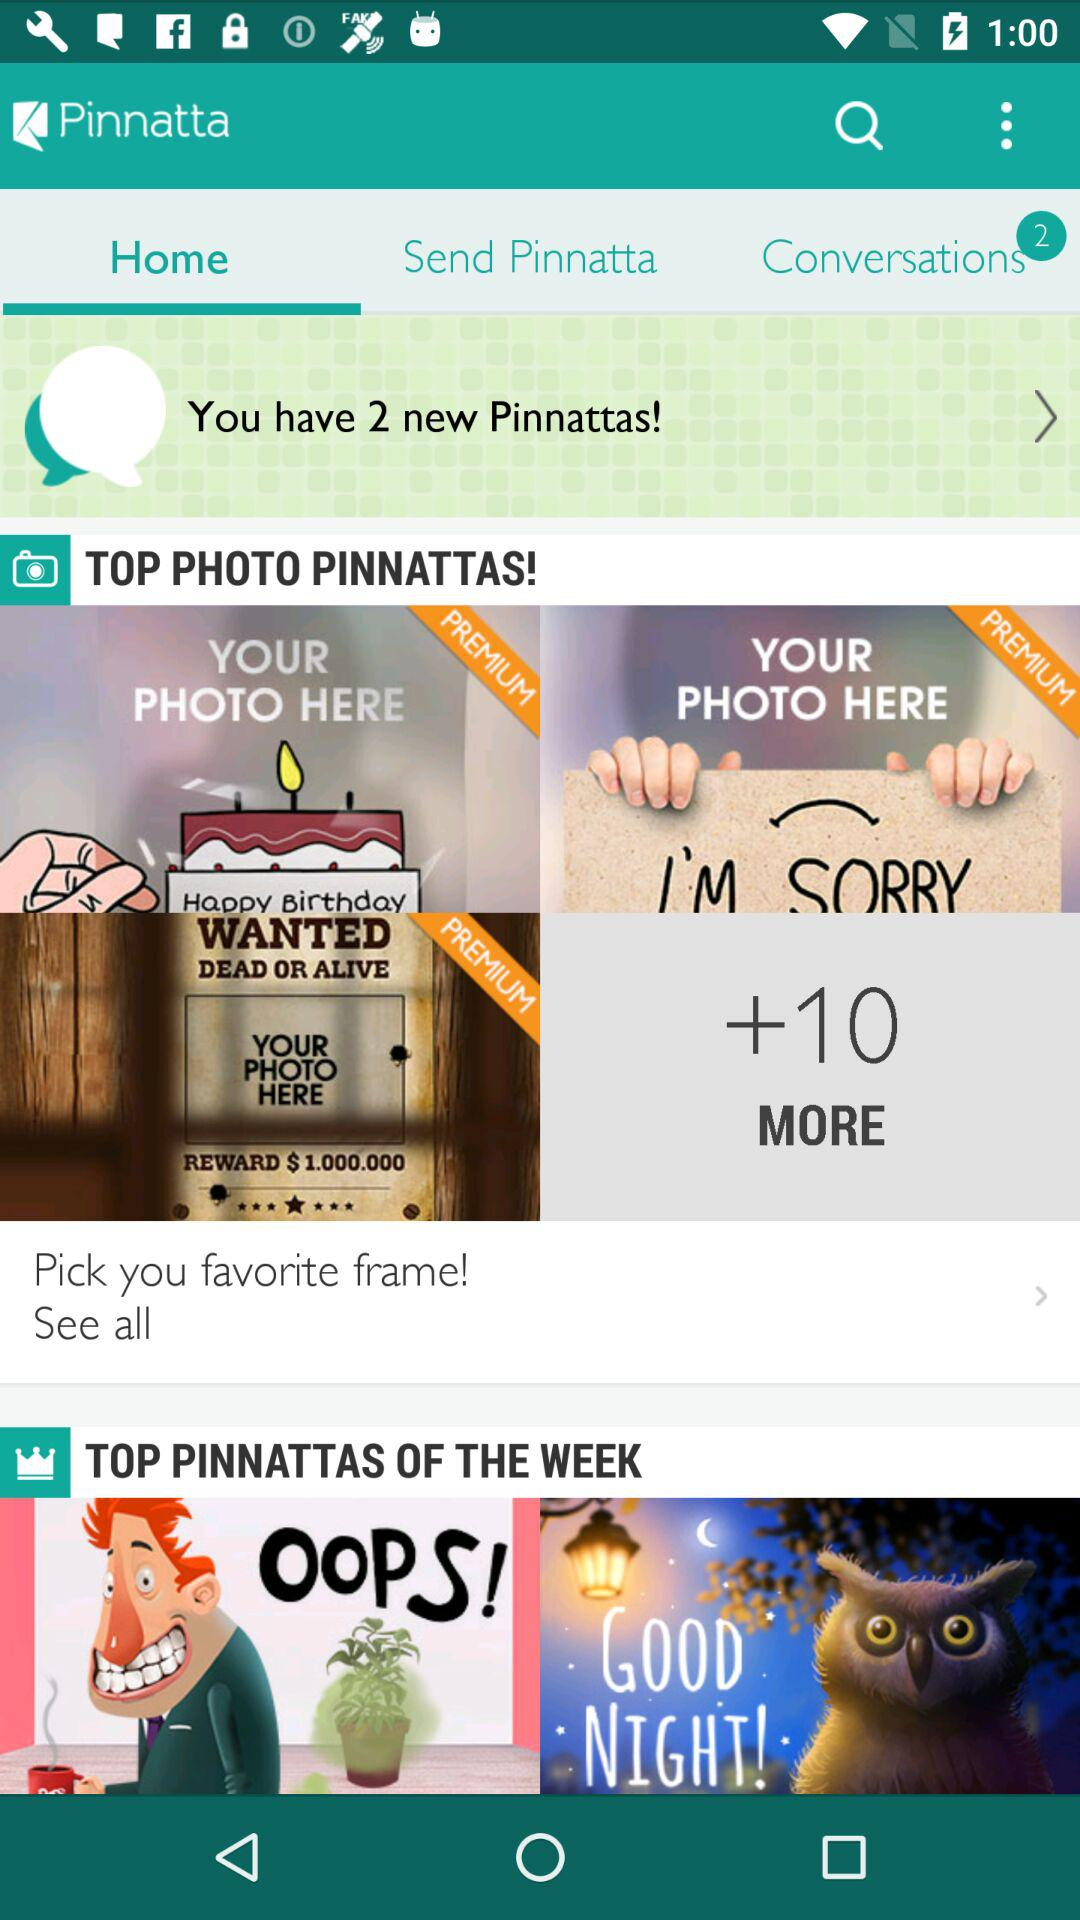What is the application name? The application name is "Pinnatta". 